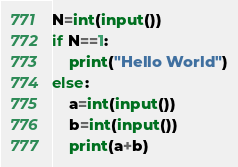Convert code to text. <code><loc_0><loc_0><loc_500><loc_500><_Python_>N=int(input())
if N==1:
    print("Hello World")
else:
    a=int(input())
    b=int(input())
    print(a+b)
</code> 